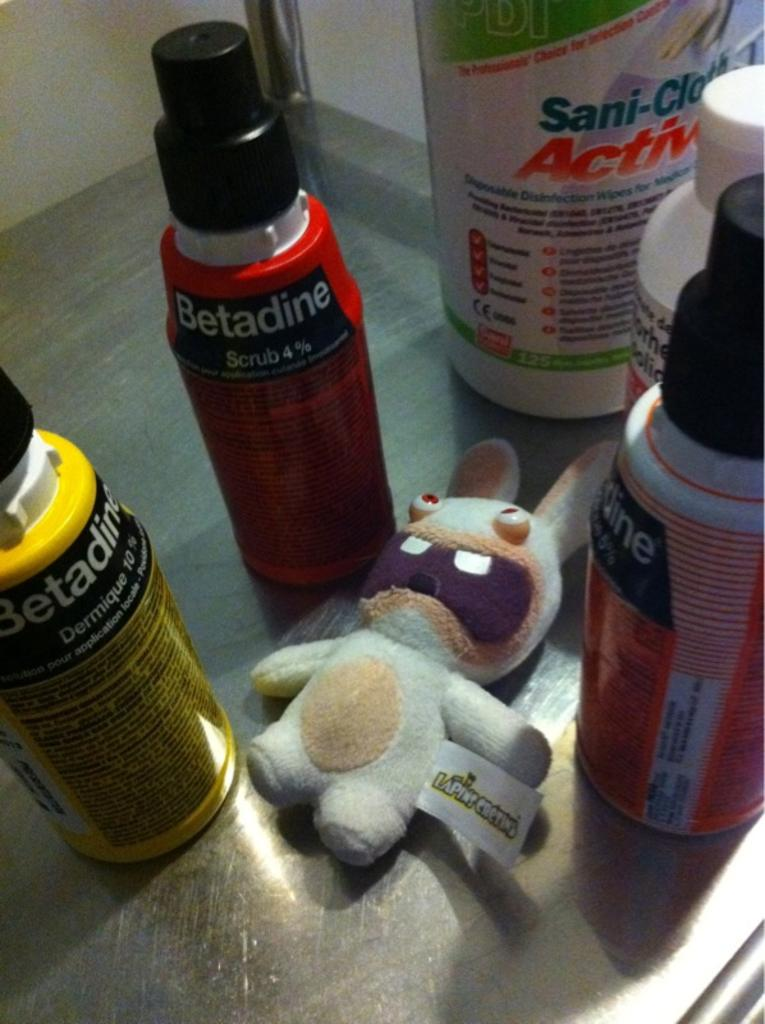What object can be seen in the image that is meant for play or entertainment? There is a toy in the image. What type of bottles are present in the image? The bottles in the image are chemical bottles. Where are the toy and bottles located in the image? The bottles and the toy are placed on the floor. What type of competition is taking place between the farmer and the border in the image? There is no farmer or border present in the image, and therefore no competition can be observed. 